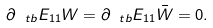Convert formula to latex. <formula><loc_0><loc_0><loc_500><loc_500>\partial _ { \ t b } E _ { 1 1 } W = \partial _ { \ t b } E _ { 1 1 } \bar { W } = 0 .</formula> 